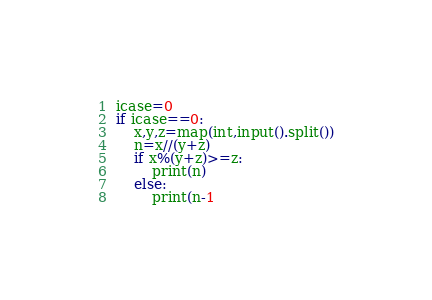<code> <loc_0><loc_0><loc_500><loc_500><_Python_>icase=0
if icase==0:
    x,y,z=map(int,input().split())
    n=x//(y+z)
    if x%(y+z)>=z:
        print(n)
    else:
        print(n-1</code> 